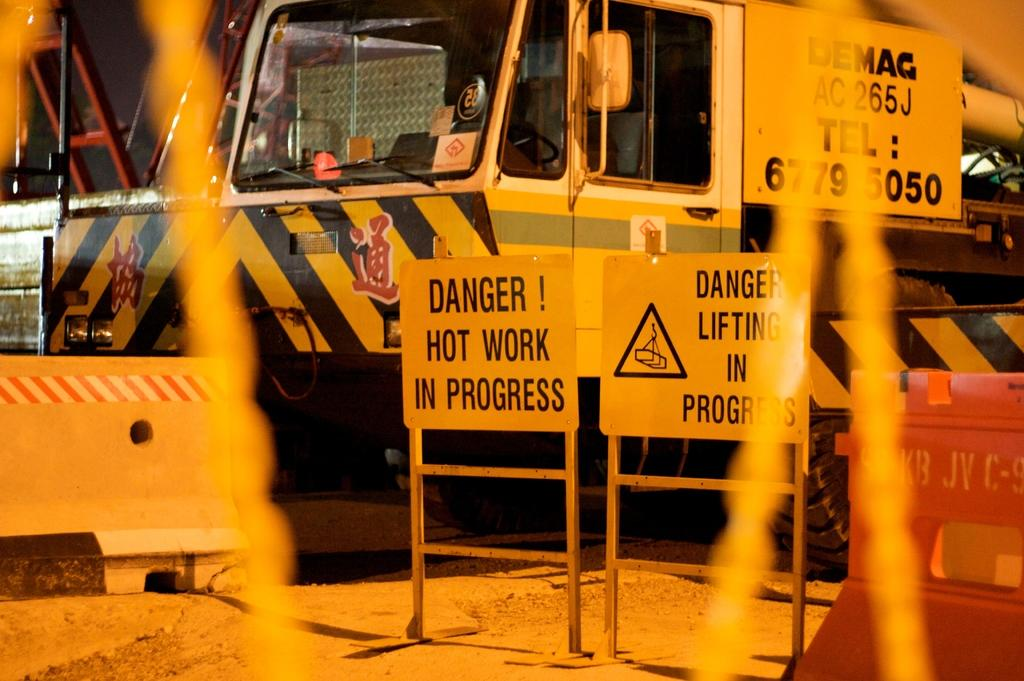<image>
Present a compact description of the photo's key features. Two yellow signs warning of danger next to a big, yellow truck. 